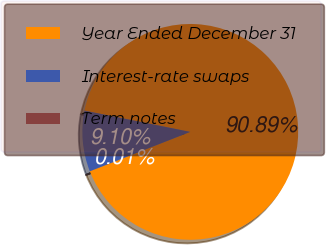<chart> <loc_0><loc_0><loc_500><loc_500><pie_chart><fcel>Year Ended December 31<fcel>Interest-rate swaps<fcel>Term notes<nl><fcel>90.89%<fcel>9.1%<fcel>0.01%<nl></chart> 